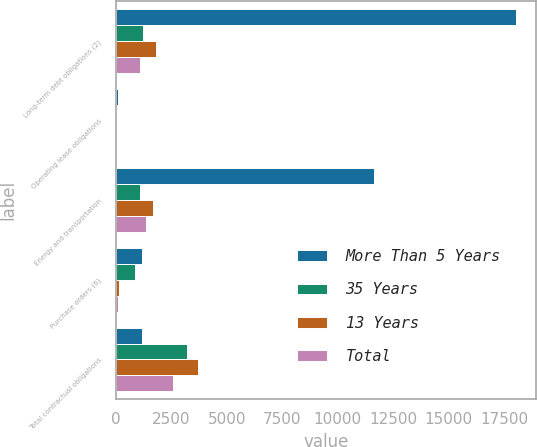<chart> <loc_0><loc_0><loc_500><loc_500><stacked_bar_chart><ecel><fcel>Long-term debt obligations (2)<fcel>Operating lease obligations<fcel>Energy and transportation<fcel>Purchase orders (6)<fcel>Total contractual obligations<nl><fcel>More Than 5 Years<fcel>18025.9<fcel>115.1<fcel>11640.9<fcel>1168.6<fcel>1168.6<nl><fcel>35 Years<fcel>1238<fcel>9.5<fcel>1084.2<fcel>851.3<fcel>3210.8<nl><fcel>13 Years<fcel>1801.1<fcel>16.8<fcel>1691.4<fcel>137.7<fcel>3714.8<nl><fcel>Total<fcel>1070.5<fcel>14.7<fcel>1369.7<fcel>77.7<fcel>2557.4<nl></chart> 